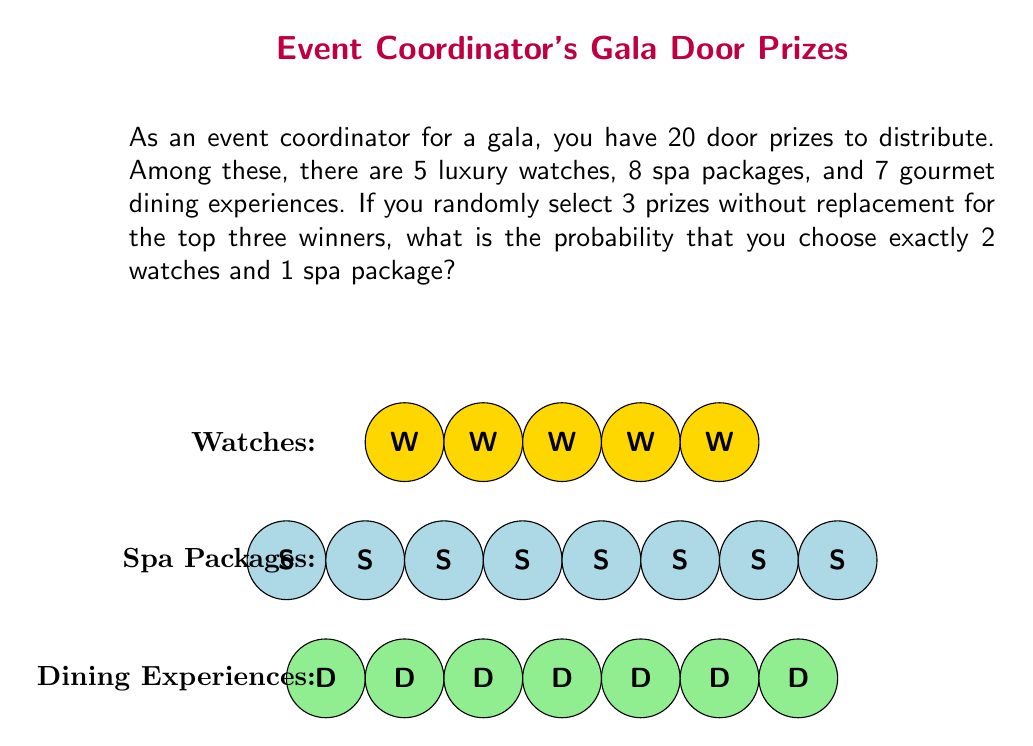Can you answer this question? Let's approach this step-by-step using the concept of combinations:

1) First, we need to calculate the total number of ways to select 3 prizes out of 20. This is given by the combination formula:

   $$\binom{20}{3} = \frac{20!}{3!(20-3)!} = \frac{20!}{3!17!} = 1140$$

2) Now, we need to calculate the number of ways to select 2 watches out of 5 and 1 spa package out of 8:

   Selecting 2 watches: $$\binom{5}{2} = \frac{5!}{2!(5-2)!} = 10$$
   Selecting 1 spa package: $$\binom{8}{1} = 8$$

3) By the multiplication principle, the number of ways to select 2 watches AND 1 spa package is:

   $$10 \times 8 = 80$$

4) The probability is then the number of favorable outcomes divided by the total number of possible outcomes:

   $$P(\text{2 watches and 1 spa package}) = \frac{80}{1140} = \frac{2}{57} \approx 0.0351$$

Thus, the probability of selecting exactly 2 watches and 1 spa package when randomly choosing 3 prizes is $\frac{2}{57}$ or about 3.51%.
Answer: $\frac{2}{57}$ 